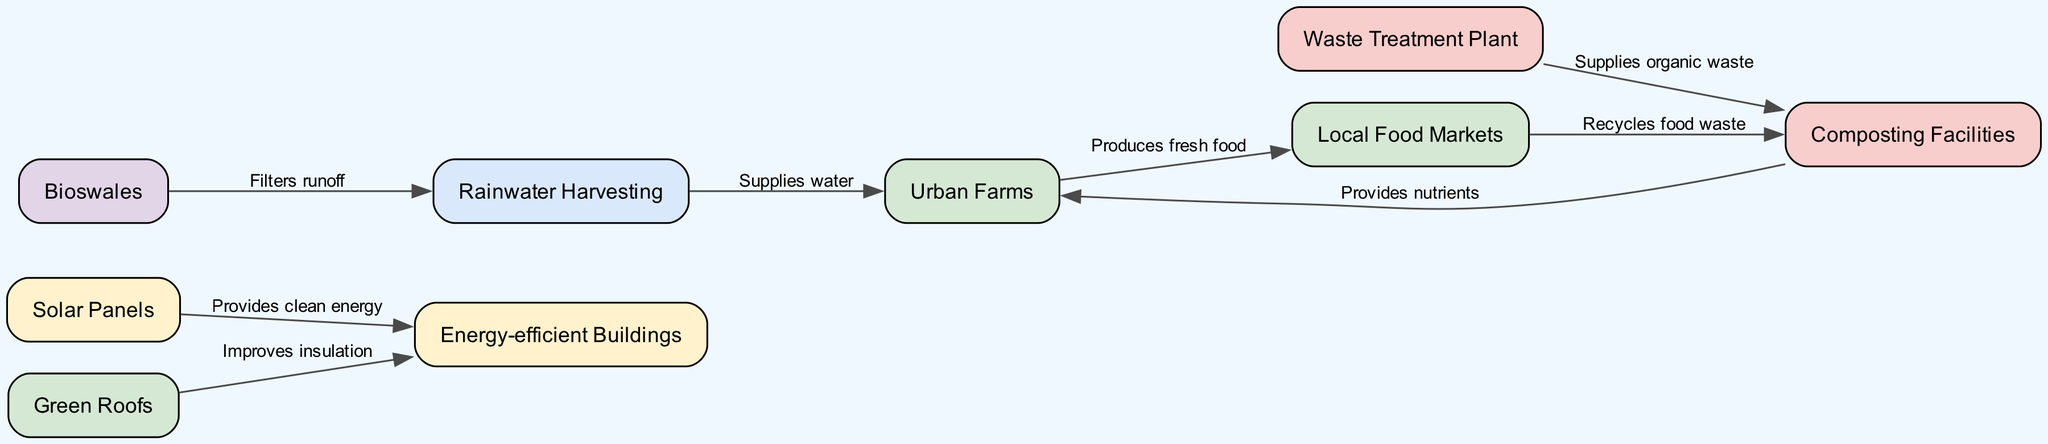What is the node that supplies clean energy? The diagram indicates that the "Solar Panels" node provides the clean energy that flows to "Energy-efficient Buildings".
Answer: Solar Panels How many nodes are present in the diagram? The diagram lists a total of 9 distinct nodes, including solar panels, green roofs, urban farms, rainwater harvesting, composting facilities, bioswales, energy-efficient buildings, waste treatment plant, and local food markets.
Answer: 9 Which node receives nutrients from composting facilities? The edge connecting "Composting Facilities" to "Urban Farms" specifies that the composting facilities provide nutrients to the urban farms.
Answer: Urban Farms What is the main product of urban farms? The diagram highlights that urban farms produce fresh food, which is then directed towards local food markets.
Answer: Fresh food How does rainwater harvesting interact with urban farms? The edge labeled "Supplies water" connects "Rainwater Harvesting" to "Urban Farms", indicating that the rainwater harvesting system directly supplies water.
Answer: Supplies water Which node filters runoff before it reaches rainwater harvesting? The connection labeled "Filters runoff" shows that "Bioswales" interact with "Rainwater Harvesting", meaning that bioswales filter the runoff before it reaches the rainwater harvesting node.
Answer: Bioswales Which two nodes are primarily involved in waste management? The nodes "Waste Treatment Plant" and "Composting Facilities" are connected by the edge labeled "Supplies organic waste", indicating their roles in waste management together.
Answer: Waste Treatment Plant and Composting Facilities From which node do local food markets recycle waste? The diagram shows an edge connecting "Local Food Markets" to "Composting Facilities", indicating that local food markets recycle food waste into the composting facilities.
Answer: Composting Facilities What function do green roofs serve in relation to energy-efficient buildings? The edge from "Green Roofs" to "Energy-efficient Buildings" is labeled "Improves insulation", illustrating that green roofs enhance the insulation within energy-efficient buildings.
Answer: Improves insulation 